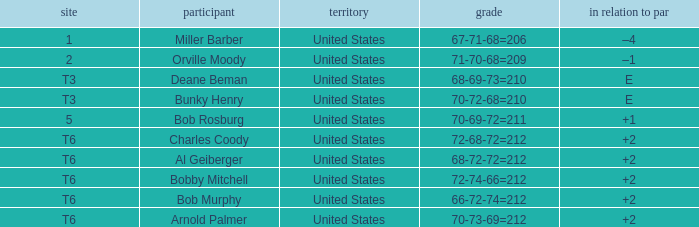What is the place of the 68-69-73=210? T3. 